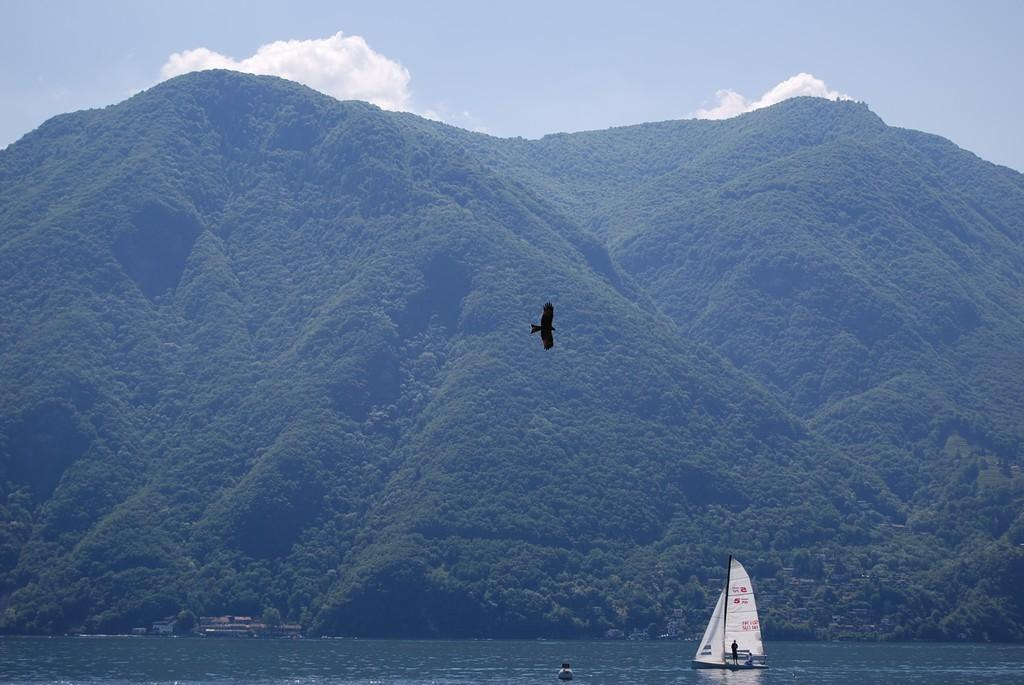What type of landscape can be seen in the image? There are hills with greenery in the image. Are there any structures near the hills? Yes, there are houses near the hills. What can be seen in the water in the image? A boat is present in the water. Who or what is on the boat? There is a person standing on the boat. What type of decision can be seen in the image? There is no decision visible in the image; it is a landscape with hills, houses, water, a boat, and a person. What type of metal is used to construct the boat in the image? The image does not provide information about the material used to construct the boat, so it cannot be determined from the image. 